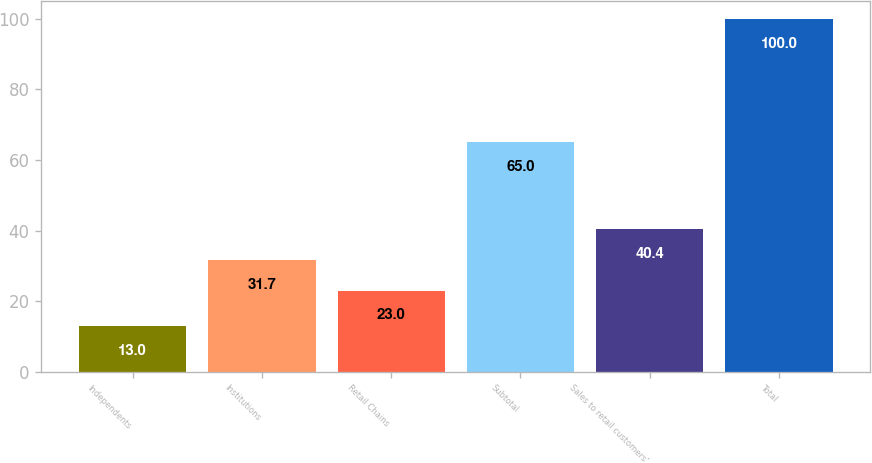Convert chart to OTSL. <chart><loc_0><loc_0><loc_500><loc_500><bar_chart><fcel>Independents<fcel>Institutions<fcel>Retail Chains<fcel>Subtotal<fcel>Sales to retail customers'<fcel>Total<nl><fcel>13<fcel>31.7<fcel>23<fcel>65<fcel>40.4<fcel>100<nl></chart> 